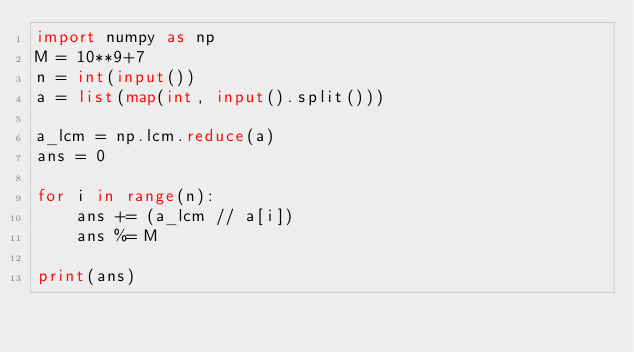Convert code to text. <code><loc_0><loc_0><loc_500><loc_500><_Python_>import numpy as np
M = 10**9+7
n = int(input())
a = list(map(int, input().split()))

a_lcm = np.lcm.reduce(a)
ans = 0

for i in range(n):
    ans += (a_lcm // a[i])
    ans %= M

print(ans)</code> 